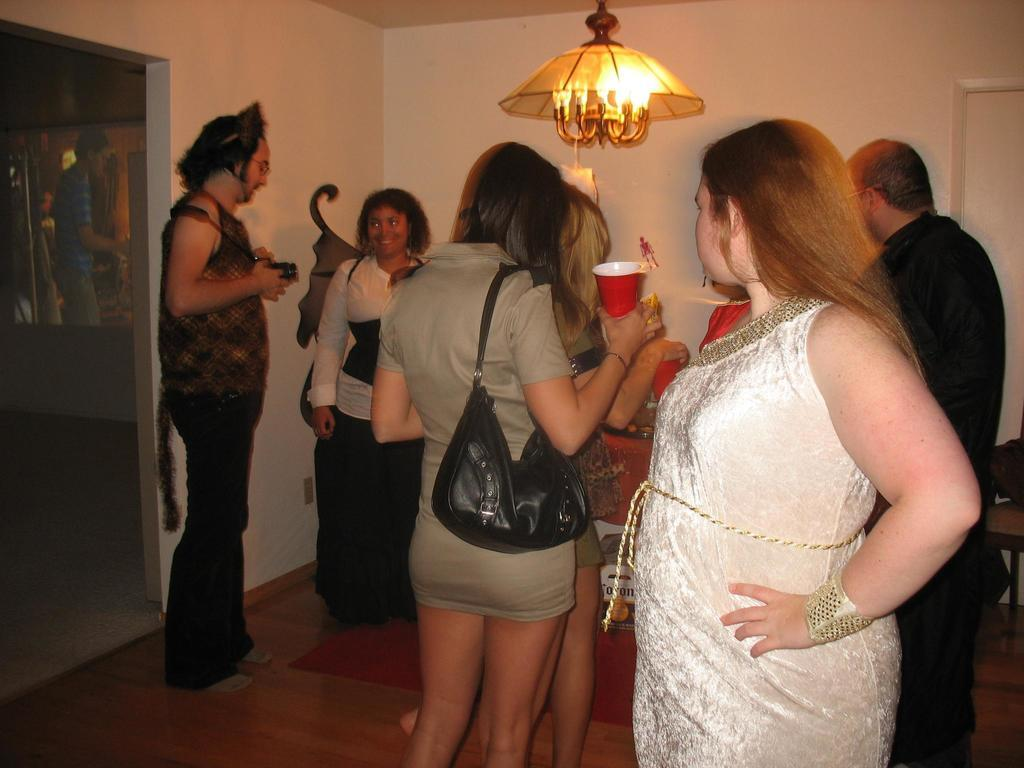What are the people in the image holding? The people in the image are holding glasses. What is the lady wearing in the image? The lady is wearing a bag in the image. Where is the lamp located in the image? The lamp is on the roof in the image. What type of development is taking place in the image? There is no indication of any development taking place in the image. Are there any police officers visible in the image? There is no mention of police officers in the image. 